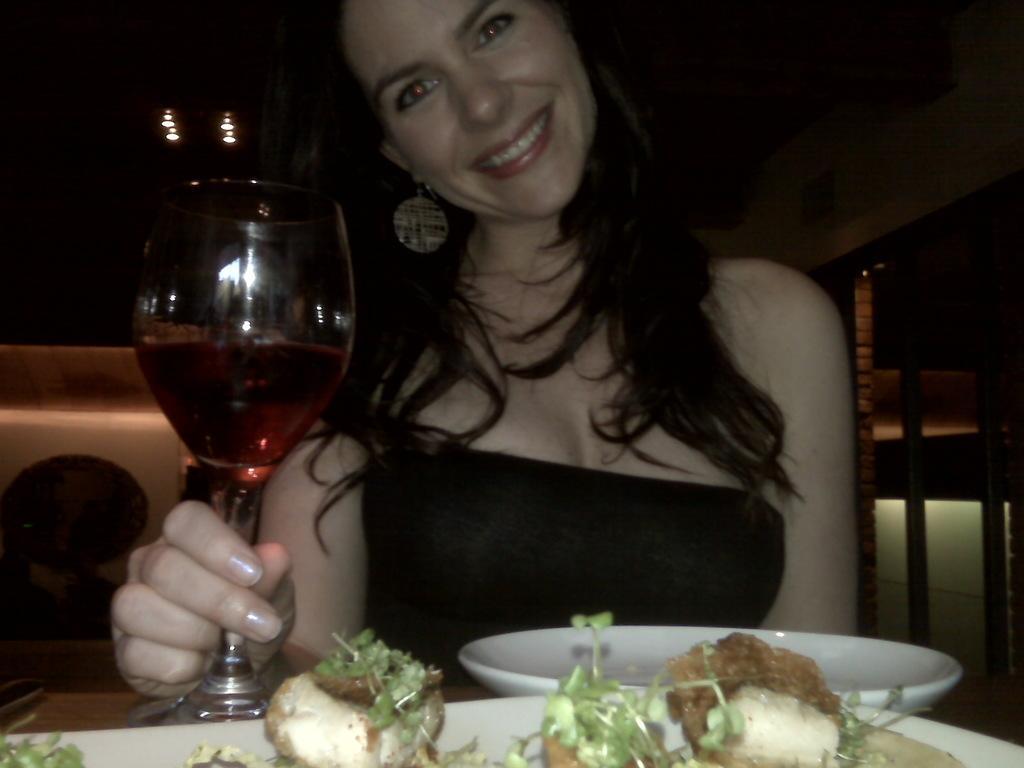Can you describe this image briefly? In this image in the center there is one woman who is sitting and she is holding a glass, and in the glass there is some drink. At the bottom there is a table, and on the table there are some plates and on the plates there is some food. And in the background there are some objects. 